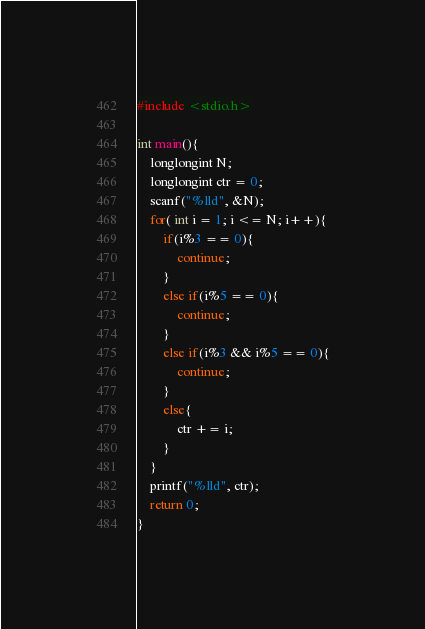Convert code to text. <code><loc_0><loc_0><loc_500><loc_500><_C++_>#include <stdio.h>

int main(){
	longlongint N;
	longlongint ctr = 0;
	scanf("%lld", &N);
	for( int i = 1; i <= N; i++){
		if(i%3 == 0){
			continue;
		}
		else if(i%5 == 0){
			continue;
		}
		else if(i%3 && i%5 == 0){
			continue;
		}
		else{
			ctr += i;
		}
	}
	printf("%lld", ctr);
	return 0;
}</code> 